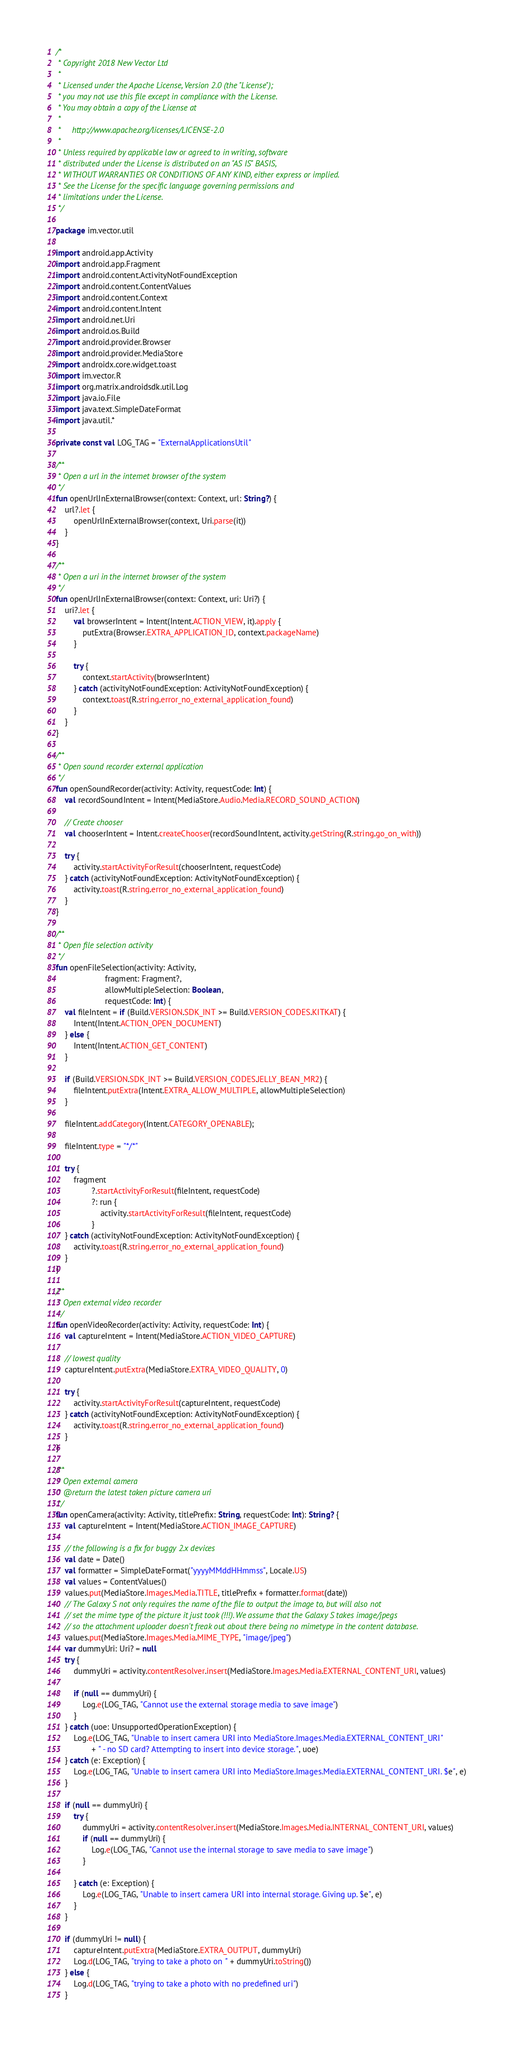<code> <loc_0><loc_0><loc_500><loc_500><_Kotlin_>/*
 * Copyright 2018 New Vector Ltd
 *
 * Licensed under the Apache License, Version 2.0 (the "License");
 * you may not use this file except in compliance with the License.
 * You may obtain a copy of the License at
 *
 *     http://www.apache.org/licenses/LICENSE-2.0
 *
 * Unless required by applicable law or agreed to in writing, software
 * distributed under the License is distributed on an "AS IS" BASIS,
 * WITHOUT WARRANTIES OR CONDITIONS OF ANY KIND, either express or implied.
 * See the License for the specific language governing permissions and
 * limitations under the License.
 */

package im.vector.util

import android.app.Activity
import android.app.Fragment
import android.content.ActivityNotFoundException
import android.content.ContentValues
import android.content.Context
import android.content.Intent
import android.net.Uri
import android.os.Build
import android.provider.Browser
import android.provider.MediaStore
import androidx.core.widget.toast
import im.vector.R
import org.matrix.androidsdk.util.Log
import java.io.File
import java.text.SimpleDateFormat
import java.util.*

private const val LOG_TAG = "ExternalApplicationsUtil"

/**
 * Open a url in the internet browser of the system
 */
fun openUrlInExternalBrowser(context: Context, url: String?) {
    url?.let {
        openUrlInExternalBrowser(context, Uri.parse(it))
    }
}

/**
 * Open a uri in the internet browser of the system
 */
fun openUrlInExternalBrowser(context: Context, uri: Uri?) {
    uri?.let {
        val browserIntent = Intent(Intent.ACTION_VIEW, it).apply {
            putExtra(Browser.EXTRA_APPLICATION_ID, context.packageName)
        }

        try {
            context.startActivity(browserIntent)
        } catch (activityNotFoundException: ActivityNotFoundException) {
            context.toast(R.string.error_no_external_application_found)
        }
    }
}

/**
 * Open sound recorder external application
 */
fun openSoundRecorder(activity: Activity, requestCode: Int) {
    val recordSoundIntent = Intent(MediaStore.Audio.Media.RECORD_SOUND_ACTION)

    // Create chooser
    val chooserIntent = Intent.createChooser(recordSoundIntent, activity.getString(R.string.go_on_with))

    try {
        activity.startActivityForResult(chooserIntent, requestCode)
    } catch (activityNotFoundException: ActivityNotFoundException) {
        activity.toast(R.string.error_no_external_application_found)
    }
}

/**
 * Open file selection activity
 */
fun openFileSelection(activity: Activity,
                      fragment: Fragment?,
                      allowMultipleSelection: Boolean,
                      requestCode: Int) {
    val fileIntent = if (Build.VERSION.SDK_INT >= Build.VERSION_CODES.KITKAT) {
        Intent(Intent.ACTION_OPEN_DOCUMENT)
    } else {
        Intent(Intent.ACTION_GET_CONTENT)
    }

    if (Build.VERSION.SDK_INT >= Build.VERSION_CODES.JELLY_BEAN_MR2) {
        fileIntent.putExtra(Intent.EXTRA_ALLOW_MULTIPLE, allowMultipleSelection)
    }

    fileIntent.addCategory(Intent.CATEGORY_OPENABLE);

    fileIntent.type = "*/*"

    try {
        fragment
                ?.startActivityForResult(fileIntent, requestCode)
                ?: run {
                    activity.startActivityForResult(fileIntent, requestCode)
                }
    } catch (activityNotFoundException: ActivityNotFoundException) {
        activity.toast(R.string.error_no_external_application_found)
    }
}

/**
 * Open external video recorder
 */
fun openVideoRecorder(activity: Activity, requestCode: Int) {
    val captureIntent = Intent(MediaStore.ACTION_VIDEO_CAPTURE)

    // lowest quality
    captureIntent.putExtra(MediaStore.EXTRA_VIDEO_QUALITY, 0)

    try {
        activity.startActivityForResult(captureIntent, requestCode)
    } catch (activityNotFoundException: ActivityNotFoundException) {
        activity.toast(R.string.error_no_external_application_found)
    }
}

/**
 * Open external camera
 * @return the latest taken picture camera uri
 */
fun openCamera(activity: Activity, titlePrefix: String, requestCode: Int): String? {
    val captureIntent = Intent(MediaStore.ACTION_IMAGE_CAPTURE)

    // the following is a fix for buggy 2.x devices
    val date = Date()
    val formatter = SimpleDateFormat("yyyyMMddHHmmss", Locale.US)
    val values = ContentValues()
    values.put(MediaStore.Images.Media.TITLE, titlePrefix + formatter.format(date))
    // The Galaxy S not only requires the name of the file to output the image to, but will also not
    // set the mime type of the picture it just took (!!!). We assume that the Galaxy S takes image/jpegs
    // so the attachment uploader doesn't freak out about there being no mimetype in the content database.
    values.put(MediaStore.Images.Media.MIME_TYPE, "image/jpeg")
    var dummyUri: Uri? = null
    try {
        dummyUri = activity.contentResolver.insert(MediaStore.Images.Media.EXTERNAL_CONTENT_URI, values)

        if (null == dummyUri) {
            Log.e(LOG_TAG, "Cannot use the external storage media to save image")
        }
    } catch (uoe: UnsupportedOperationException) {
        Log.e(LOG_TAG, "Unable to insert camera URI into MediaStore.Images.Media.EXTERNAL_CONTENT_URI"
                + " - no SD card? Attempting to insert into device storage.", uoe)
    } catch (e: Exception) {
        Log.e(LOG_TAG, "Unable to insert camera URI into MediaStore.Images.Media.EXTERNAL_CONTENT_URI. $e", e)
    }

    if (null == dummyUri) {
        try {
            dummyUri = activity.contentResolver.insert(MediaStore.Images.Media.INTERNAL_CONTENT_URI, values)
            if (null == dummyUri) {
                Log.e(LOG_TAG, "Cannot use the internal storage to save media to save image")
            }

        } catch (e: Exception) {
            Log.e(LOG_TAG, "Unable to insert camera URI into internal storage. Giving up. $e", e)
        }
    }

    if (dummyUri != null) {
        captureIntent.putExtra(MediaStore.EXTRA_OUTPUT, dummyUri)
        Log.d(LOG_TAG, "trying to take a photo on " + dummyUri.toString())
    } else {
        Log.d(LOG_TAG, "trying to take a photo with no predefined uri")
    }
</code> 